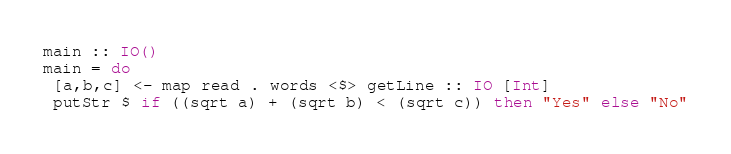<code> <loc_0><loc_0><loc_500><loc_500><_Haskell_>main :: IO()
main = do
 [a,b,c] <- map read . words <$> getLine :: IO [Int]
 putStr $ if ((sqrt a) + (sqrt b) < (sqrt c)) then "Yes" else "No"</code> 